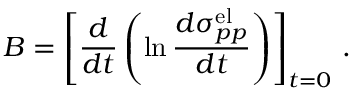Convert formula to latex. <formula><loc_0><loc_0><loc_500><loc_500>B = \left [ { \frac { d } { d t } } \left ( \ln { \frac { d \sigma _ { p p } ^ { e l } } { d t } } \right ) \right ] _ { t = 0 } \, .</formula> 